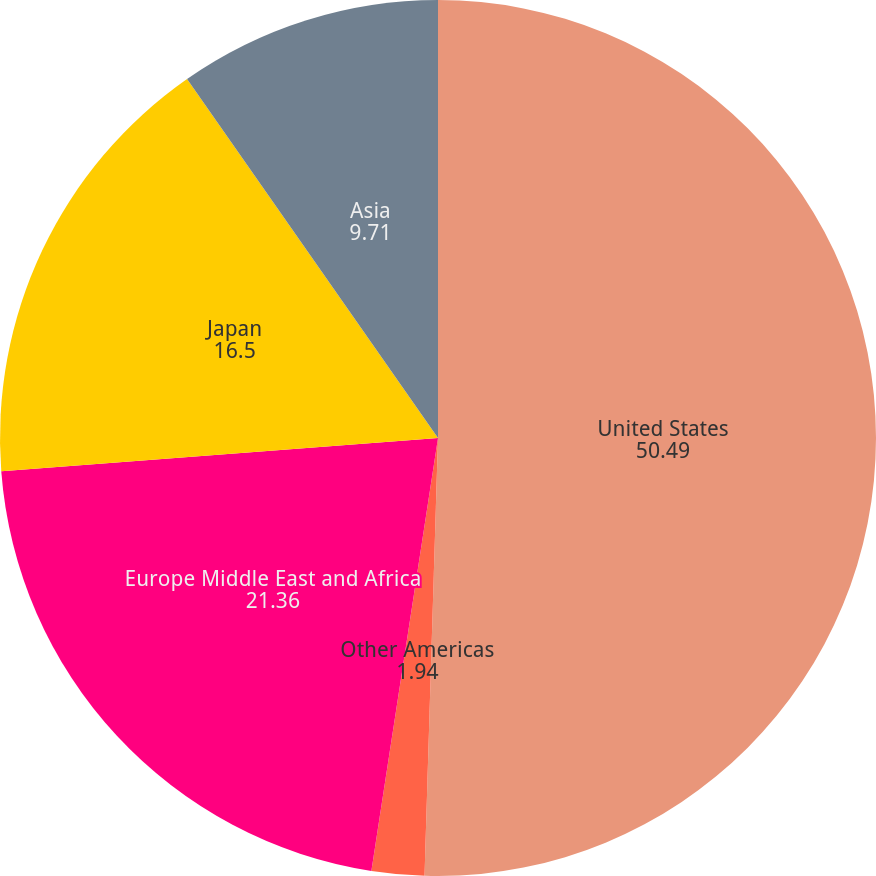<chart> <loc_0><loc_0><loc_500><loc_500><pie_chart><fcel>United States<fcel>Other Americas<fcel>Europe Middle East and Africa<fcel>Japan<fcel>Asia<nl><fcel>50.49%<fcel>1.94%<fcel>21.36%<fcel>16.5%<fcel>9.71%<nl></chart> 